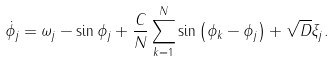Convert formula to latex. <formula><loc_0><loc_0><loc_500><loc_500>\dot { \phi _ { j } } = \omega _ { j } - \sin \phi _ { j } + \frac { C } { N } \sum _ { k = 1 } ^ { N } \sin \left ( \phi _ { k } - \phi _ { j } \right ) + \sqrt { D } \xi _ { j } .</formula> 